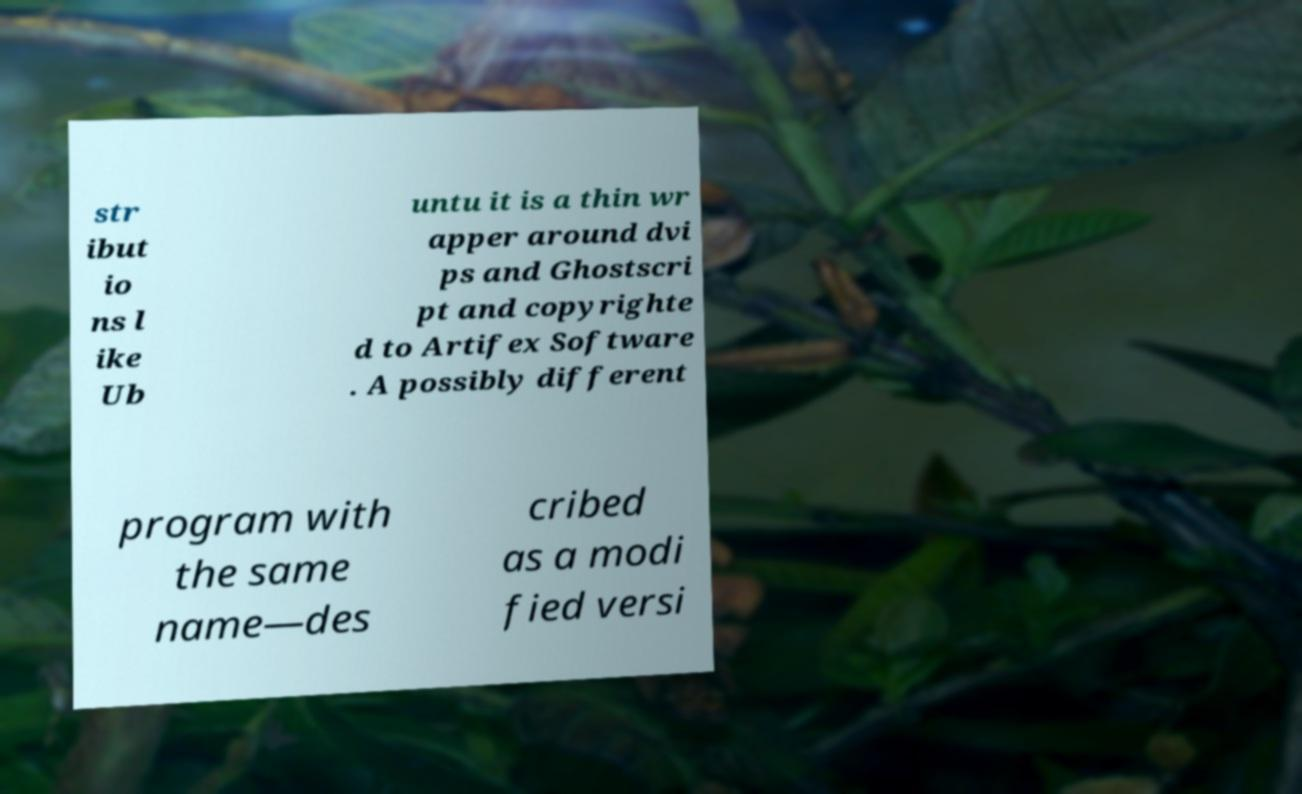Can you read and provide the text displayed in the image?This photo seems to have some interesting text. Can you extract and type it out for me? str ibut io ns l ike Ub untu it is a thin wr apper around dvi ps and Ghostscri pt and copyrighte d to Artifex Software . A possibly different program with the same name—des cribed as a modi fied versi 